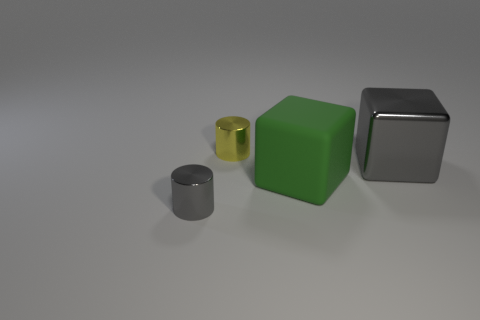Is the number of tiny yellow shiny cylinders greater than the number of large metal cylinders?
Offer a very short reply. Yes. Is there anything else that is the same color as the large metallic thing?
Your answer should be very brief. Yes. What number of other objects are there of the same size as the metallic block?
Give a very brief answer. 1. What is the material of the large green block behind the object left of the tiny thing behind the small gray object?
Offer a terse response. Rubber. Does the tiny yellow object have the same material as the gray cube that is to the right of the small gray metallic cylinder?
Your answer should be very brief. Yes. Is the number of cubes to the right of the large green block less than the number of metallic objects on the left side of the metal block?
Ensure brevity in your answer.  Yes. How many gray things are the same material as the tiny yellow object?
Offer a very short reply. 2. Is there a metallic block that is right of the metal cylinder on the right side of the gray metal thing that is in front of the large gray cube?
Your response must be concise. Yes. What number of spheres are big green rubber things or small things?
Give a very brief answer. 0. There is a small yellow thing; does it have the same shape as the small object in front of the shiny block?
Ensure brevity in your answer.  Yes. 